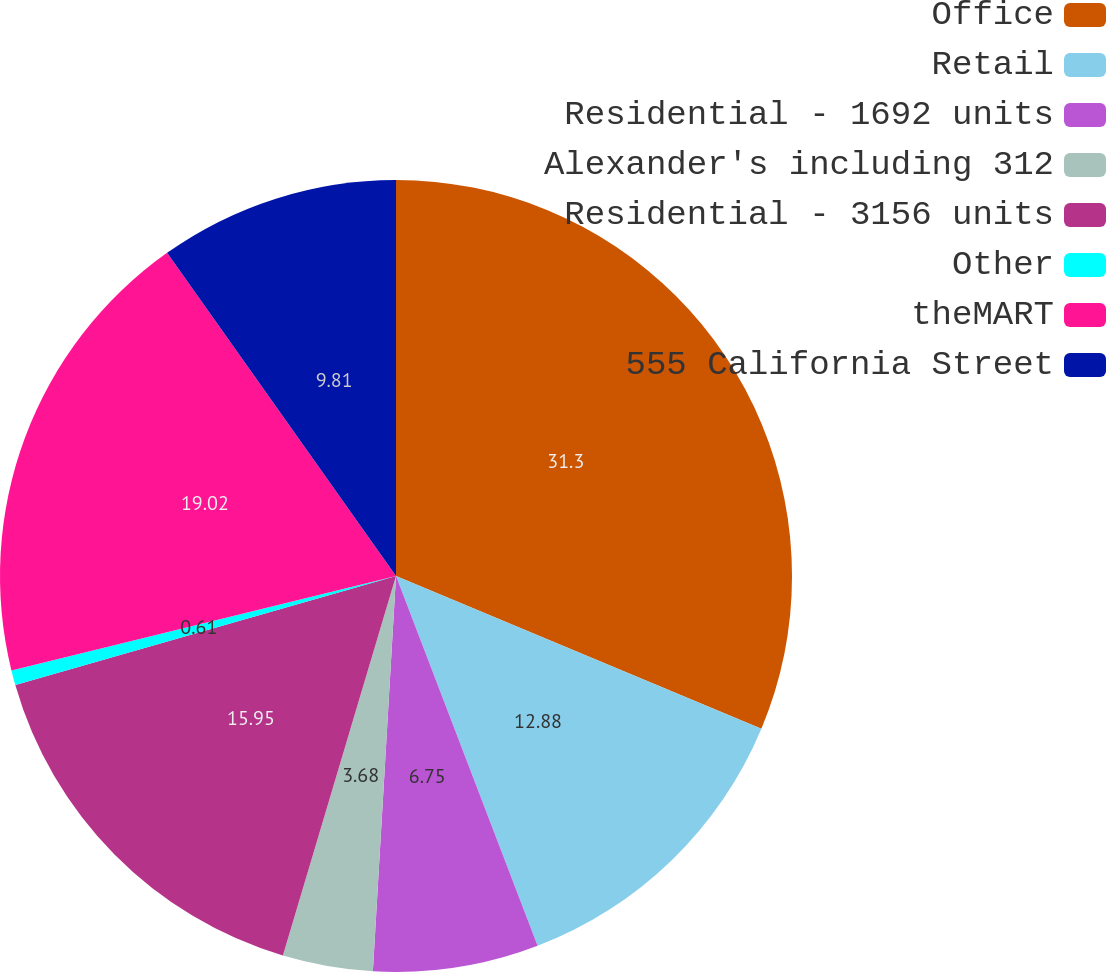<chart> <loc_0><loc_0><loc_500><loc_500><pie_chart><fcel>Office<fcel>Retail<fcel>Residential - 1692 units<fcel>Alexander's including 312<fcel>Residential - 3156 units<fcel>Other<fcel>theMART<fcel>555 California Street<nl><fcel>31.3%<fcel>12.88%<fcel>6.75%<fcel>3.68%<fcel>15.95%<fcel>0.61%<fcel>19.02%<fcel>9.81%<nl></chart> 